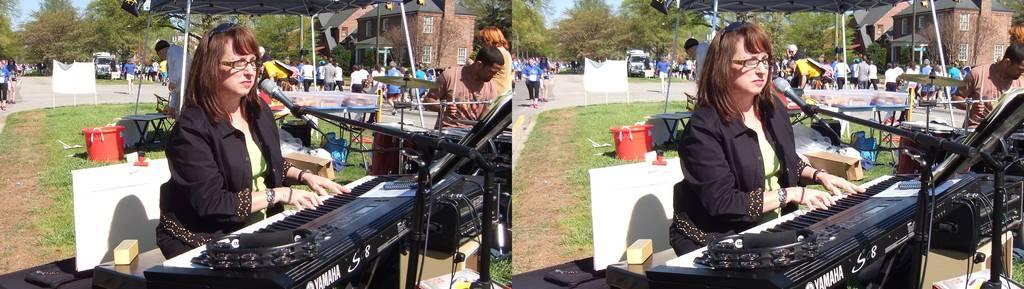Can you describe this image briefly? In the image we can see collage photos, into collage photos we can see a woman sitting, wearing clothes, spectacles, wrist watch and she is playing musical instrument. Here we can see grass and there are many other people standing and some of them are walking. Here we can see the building, trees and the sky. 